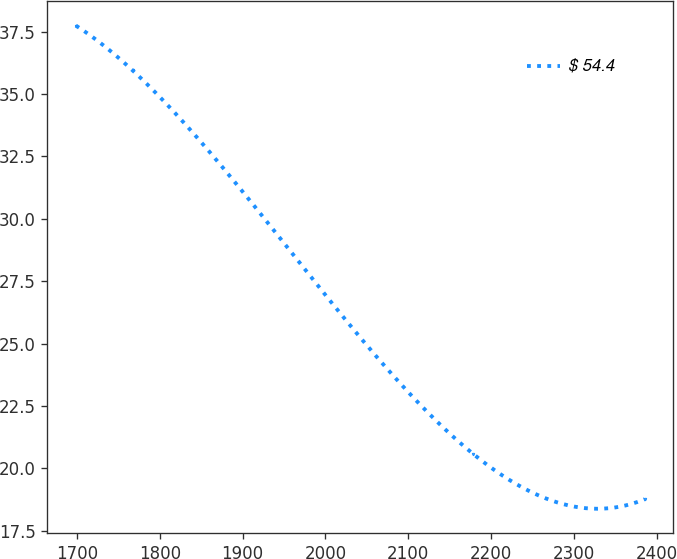Convert chart to OTSL. <chart><loc_0><loc_0><loc_500><loc_500><line_chart><ecel><fcel>$ 54.4<nl><fcel>1698.72<fcel>37.74<nl><fcel>1767.37<fcel>35.94<nl><fcel>2177.83<fcel>20.59<nl><fcel>2385.25<fcel>18.76<nl></chart> 